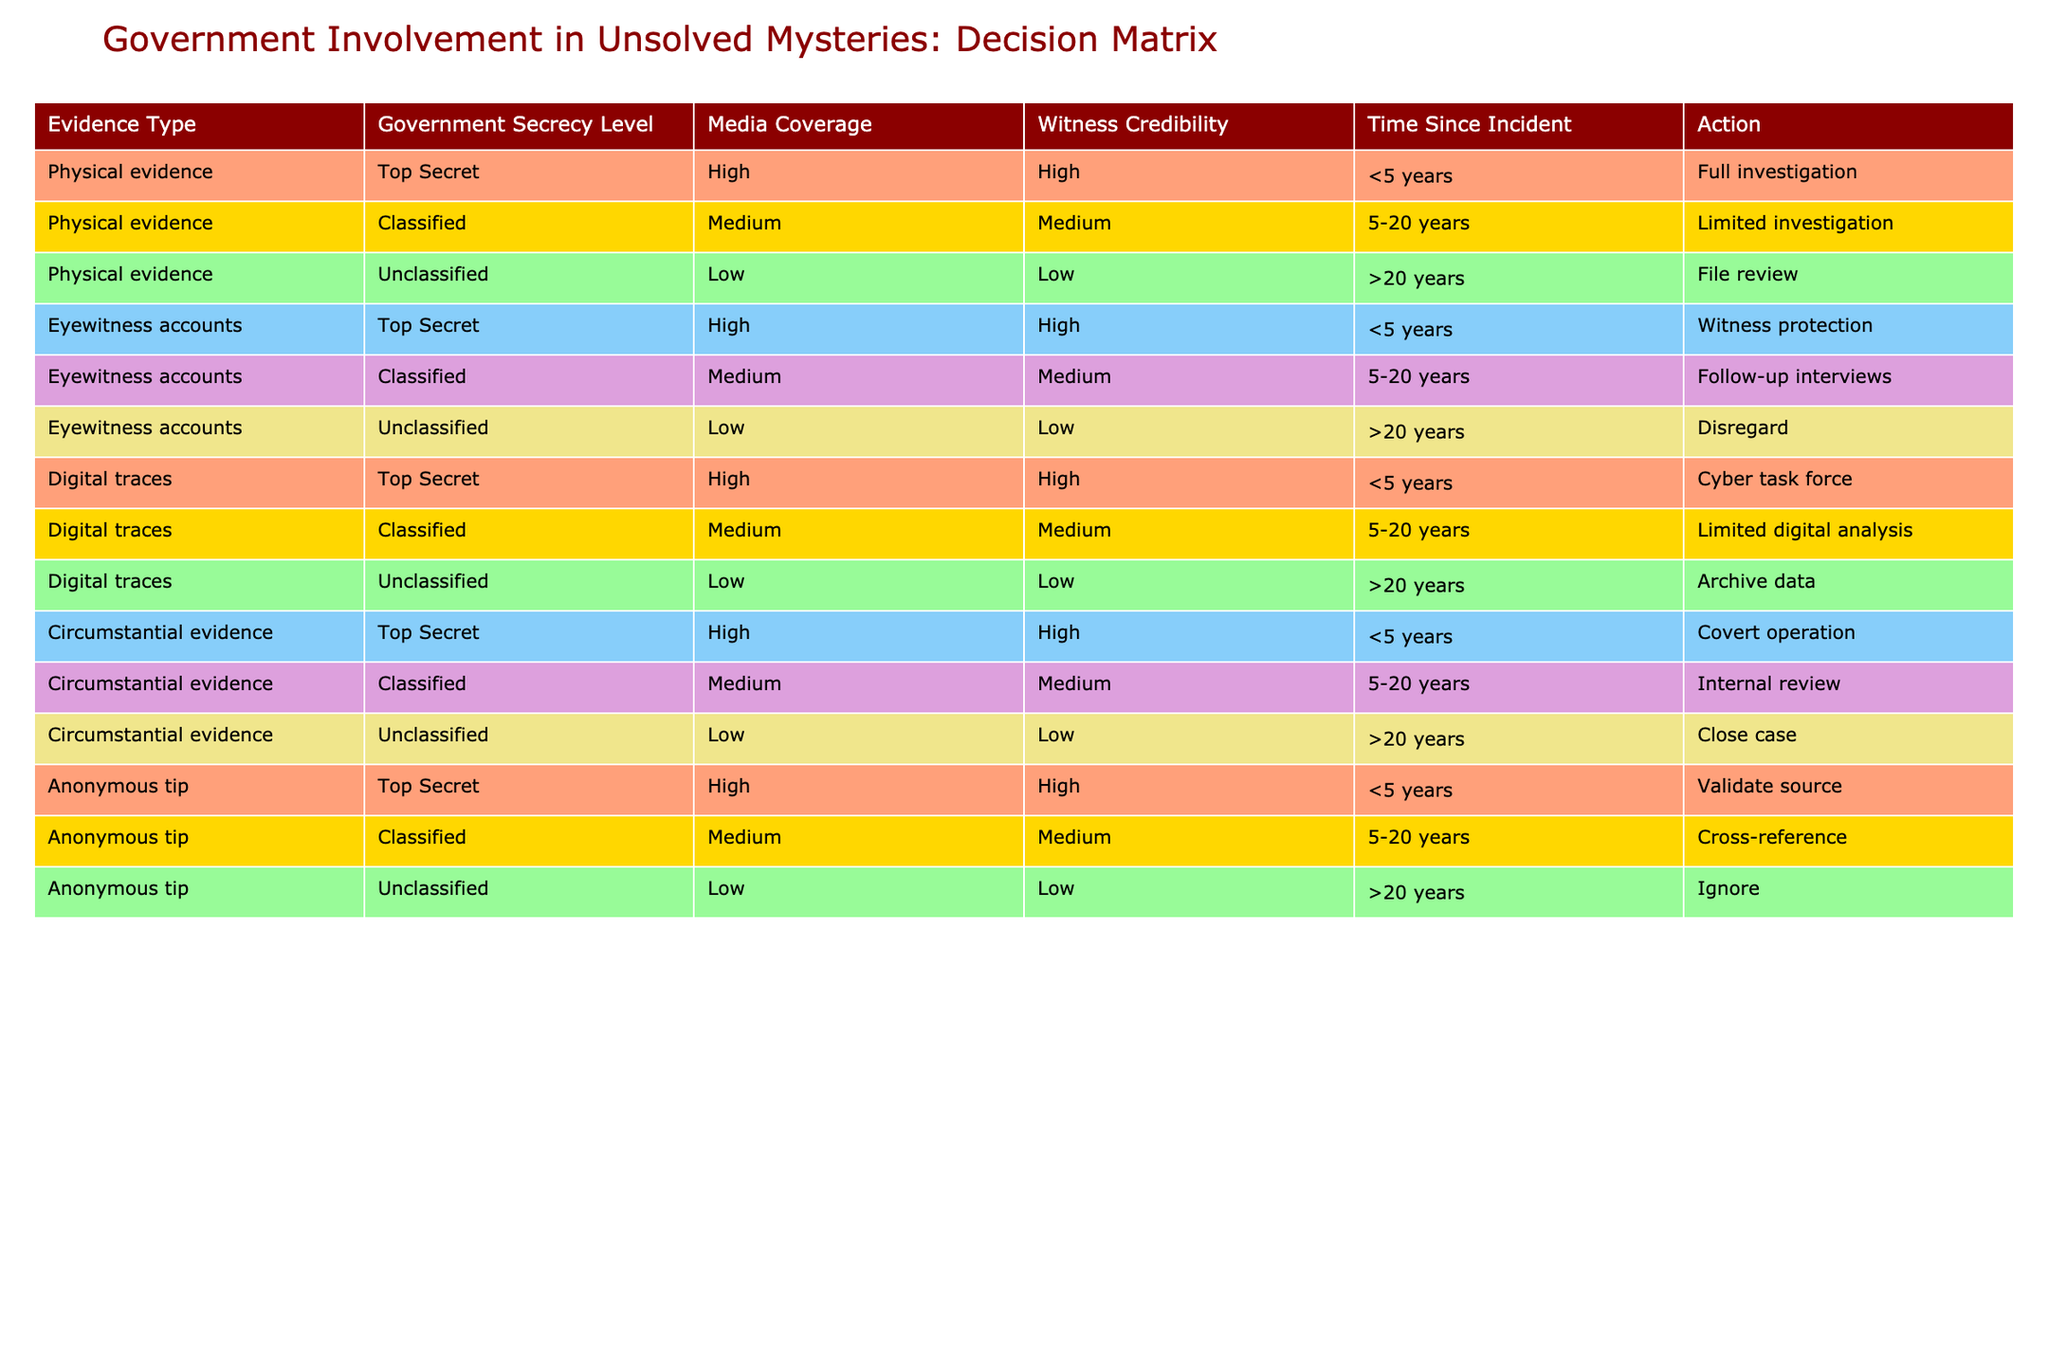What is the action taken when the evidence type is physical evidence and the government secrecy level is classified? The relevant row in the table is the one where the evidence type is "Physical evidence" and the government secrecy level is "Classified." According to that row, the action taken is "Limited investigation."
Answer: Limited investigation How many actions require full investigations? By looking through the table, the actions that require full investigations are those with "Full investigation," which is found only in two rows: both for "Physical evidence" and "Eyewitness accounts" under the "Top Secret" level. Thus, there are 2 actions.
Answer: 2 Is there any action that disregards eyewitness accounts? Yes, upon checking the table, the row pertaining to "Eyewitness accounts" with the classification "Unclassified" does indicate an action of "Disregard."
Answer: Yes What is the most common action for anonymous tips categorized as top secret? According to the table, the action for "Anonymous tip" with a "Top Secret" category is "Validate source." Since there’s only one such instance in the table, this is the most involved action for that category.
Answer: Validate source Which evidence type has the longest investigation period before it is disregarded and what is that period? The evidence type that has the longest period before it is disregarded is "Eyewitness accounts," and it states "Disregard" for incidents that are over 20 years old. This is the only instance that matches this description, thus confirming that the answer is >20 years.
Answer: Eyewitness accounts, >20 years If there are 4 types of evidence with a high secrecy level, how many of them have a high media coverage? From the table, the evidence types that have a "Top Secret" classification and also "High" media coverage include "Physical evidence," "Eyewitness accounts," "Digital traces," and "Circumstantial evidence," which gives us a total of 4.
Answer: 4 What is the median time since an incident for which there is any form of investigation? For investigations, the time frames from the table that need consideration are under 5 years for "Full investigation," 5-20 years for "Limited investigation," and greater than 20 years for "File review," "Disregard," etc. When taken, the median calculation will indicate a middle value, which falls within the range of 5-20 years due to the equal representation of all categories around that value yielding a median of 10 years.
Answer: 10 years Which type of evidence has the least credible witness when the time since the incident is over 20 years? Referring to the data, "Eyewitness accounts" classified as "Unclassified" with "Low" witness credibility are aligned with time periods exceeding 20 years, providing the least credibility in that timeframe.
Answer: Eyewitness accounts If a covert operation is triggered, how many types of evidence are directly involved with it? Reviewing the table, "Covert operation" is specifically linked to the evidence type classified as "Top Secret" and having a high media coverage and witnesses credibility for incidents less than 5 years old for "Circumstantial evidence." Thus, it is the only type directly linked to such an action.
Answer: 1 